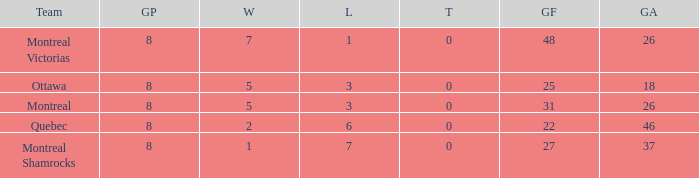How many losses did the team with 22 goals for andmore than 8 games played have? 0.0. 